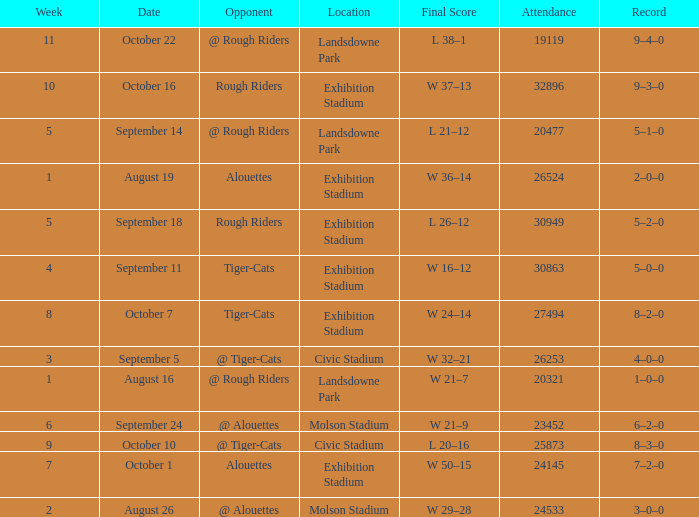How many values for attendance on the date of August 26? 1.0. 